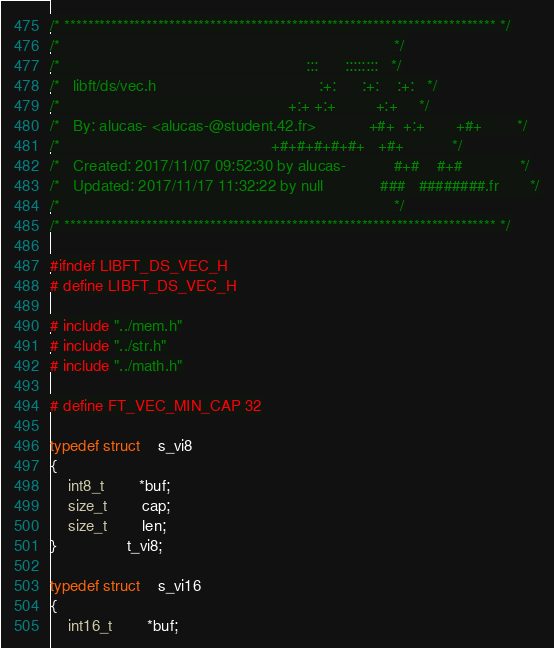Convert code to text. <code><loc_0><loc_0><loc_500><loc_500><_C_>/* ************************************************************************** */
/*                                                                            */
/*                                                        :::      ::::::::   */
/*   libft/ds/vec.h                                     :+:      :+:    :+:   */
/*                                                    +:+ +:+         +:+     */
/*   By: alucas- <alucas-@student.42.fr>            +#+  +:+       +#+        */
/*                                                +#+#+#+#+#+   +#+           */
/*   Created: 2017/11/07 09:52:30 by alucas-           #+#    #+#             */
/*   Updated: 2017/11/17 11:32:22 by null             ###   ########.fr       */
/*                                                                            */
/* ************************************************************************** */

#ifndef LIBFT_DS_VEC_H
# define LIBFT_DS_VEC_H

# include "../mem.h"
# include "../str.h"
# include "../math.h"

# define FT_VEC_MIN_CAP 32

typedef struct	s_vi8
{
	int8_t		*buf;
	size_t		cap;
	size_t		len;
}				t_vi8;

typedef struct	s_vi16
{
	int16_t		*buf;</code> 